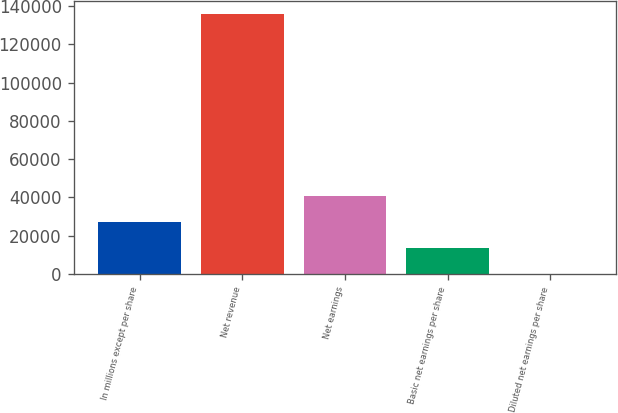Convert chart. <chart><loc_0><loc_0><loc_500><loc_500><bar_chart><fcel>In millions except per share<fcel>Net revenue<fcel>Net earnings<fcel>Basic net earnings per share<fcel>Diluted net earnings per share<nl><fcel>27206.8<fcel>136022<fcel>40808.8<fcel>13605<fcel>3.05<nl></chart> 